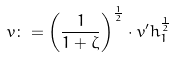Convert formula to latex. <formula><loc_0><loc_0><loc_500><loc_500>v \colon = \left ( \frac { 1 } { 1 + \zeta } \right ) ^ { \frac { 1 } { 2 } } \cdot v ^ { \prime } h _ { 1 } ^ { \frac { 1 } { 2 } }</formula> 